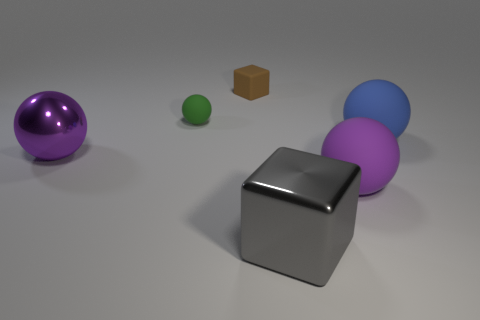What is the shape of the big metallic object that is to the left of the green sphere?
Your answer should be compact. Sphere. The small rubber cube has what color?
Make the answer very short. Brown. There is a green matte thing; does it have the same size as the cube behind the blue object?
Provide a short and direct response. Yes. How many rubber objects are either small blue spheres or small things?
Make the answer very short. 2. There is a big shiny ball; does it have the same color as the big sphere in front of the metallic sphere?
Offer a terse response. Yes. The brown thing is what shape?
Provide a short and direct response. Cube. How big is the cube that is behind the big ball that is right of the big rubber thing that is in front of the large purple shiny ball?
Keep it short and to the point. Small. How many other things are there of the same shape as the small green matte thing?
Ensure brevity in your answer.  3. There is a large rubber object on the left side of the large blue matte object; is it the same shape as the big purple thing that is on the left side of the rubber block?
Ensure brevity in your answer.  Yes. What number of balls are big matte things or tiny green things?
Give a very brief answer. 3. 